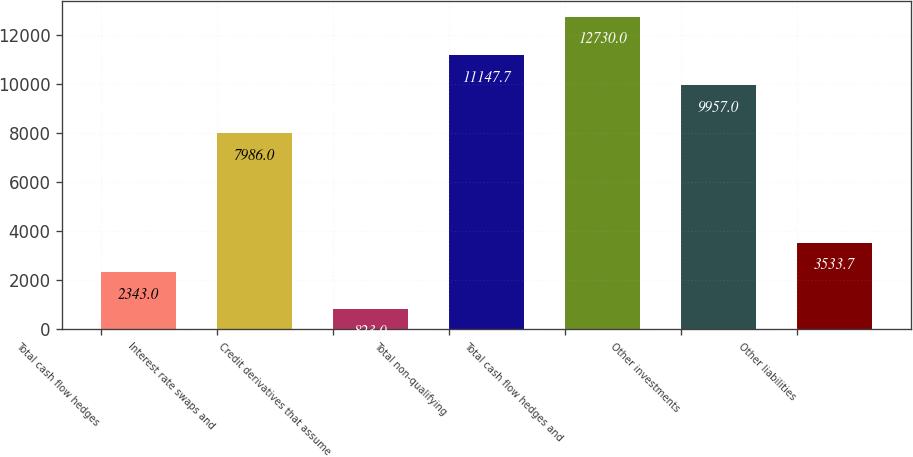Convert chart. <chart><loc_0><loc_0><loc_500><loc_500><bar_chart><fcel>Total cash flow hedges<fcel>Interest rate swaps and<fcel>Credit derivatives that assume<fcel>Total non-qualifying<fcel>Total cash flow hedges and<fcel>Other investments<fcel>Other liabilities<nl><fcel>2343<fcel>7986<fcel>823<fcel>11147.7<fcel>12730<fcel>9957<fcel>3533.7<nl></chart> 